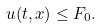<formula> <loc_0><loc_0><loc_500><loc_500>u ( t , x ) \leq F _ { 0 } .</formula> 